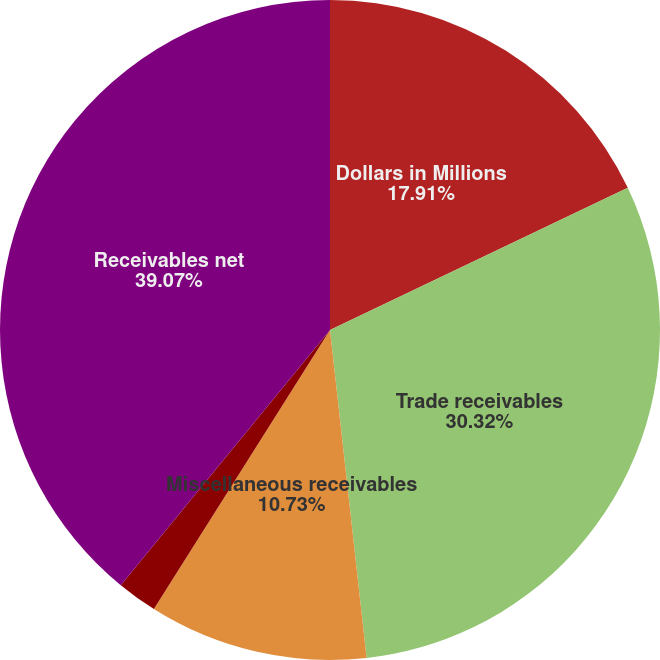Convert chart. <chart><loc_0><loc_0><loc_500><loc_500><pie_chart><fcel>Dollars in Millions<fcel>Trade receivables<fcel>Miscellaneous receivables<fcel>Less allowances<fcel>Receivables net<nl><fcel>17.91%<fcel>30.32%<fcel>10.73%<fcel>1.97%<fcel>39.07%<nl></chart> 